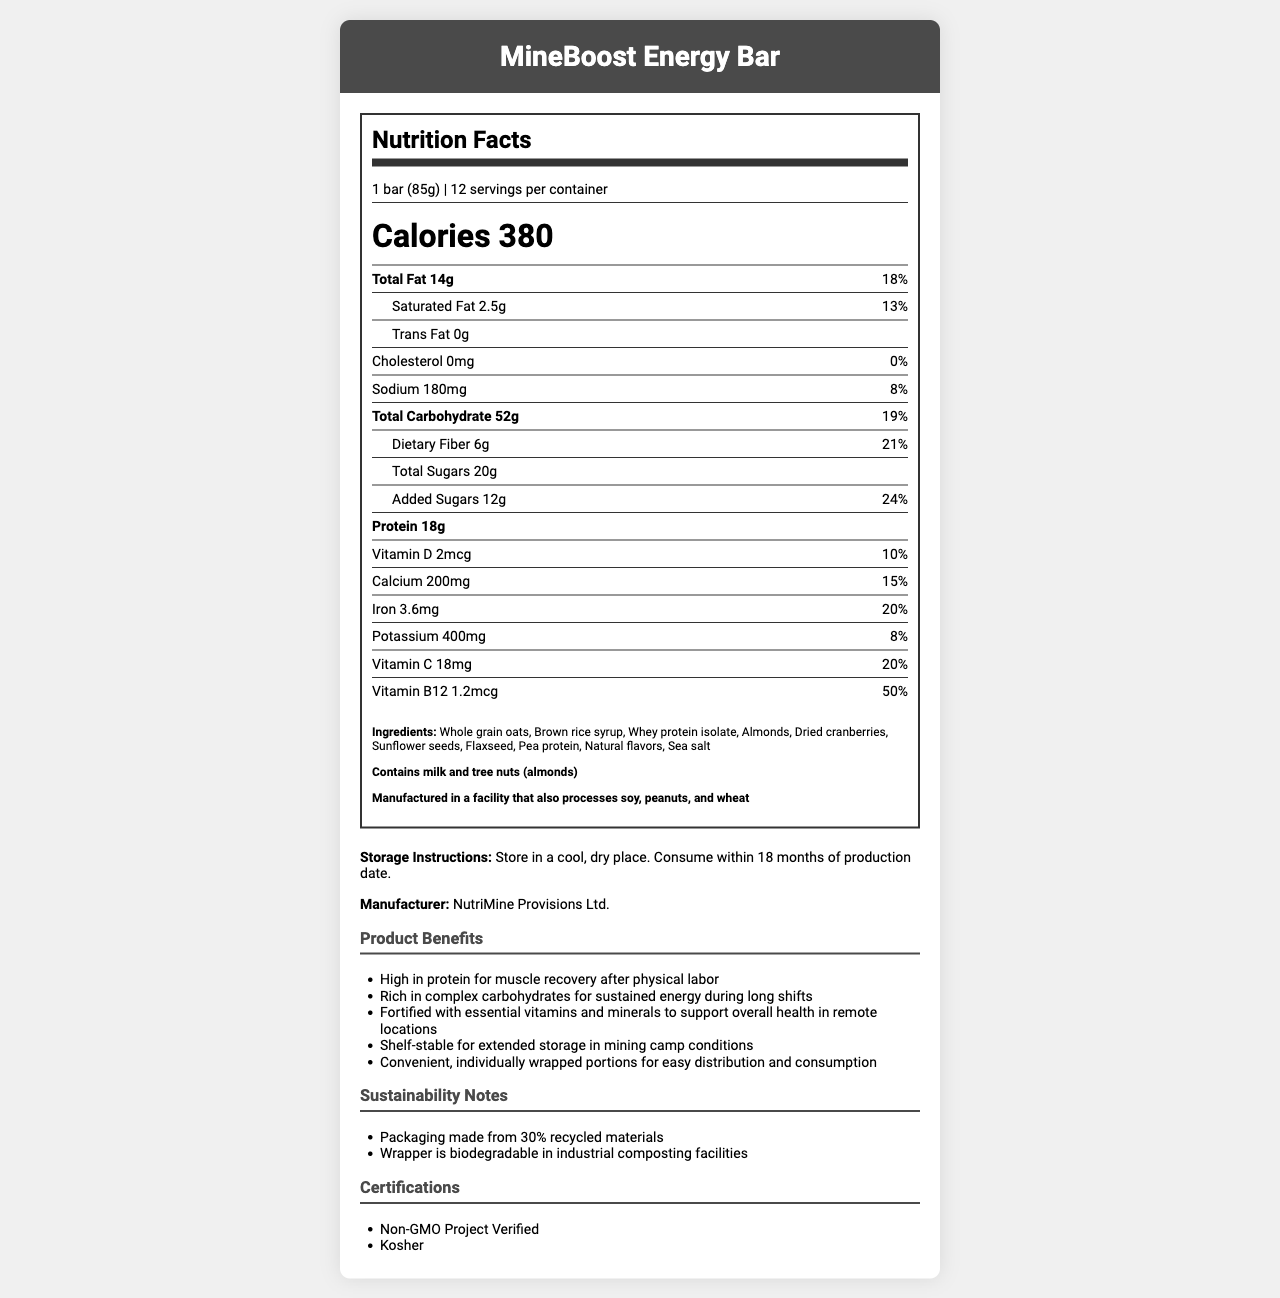what is the serving size of the MineBoost Energy Bar? The serving size of the MineBoost Energy Bar is indicated as "1 bar (85g)" in the Nutrition Facts section.
Answer: 1 bar (85g) how many calories are in one serving of the MineBoost Energy Bar? The Nutrition Facts section shows that one serving contains 380 calories.
Answer: 380 what is the amount of protein in one bar? The protein content per serving is listed as 18g in the Nutrition Facts section.
Answer: 18g list the vitamins and minerals included in the MineBoost Energy Bar. The Nutrition Facts section lists these vitamins and minerals with their amounts and daily values.
Answer: Vitamin D, Calcium, Iron, Potassium, Vitamin C, Vitamin B12 what is the daily value percentage for dietary fiber? The daily value percentage for dietary fiber is stated as 21% in the Nutrition Facts section.
Answer: 21% what are the main sources of protein in the MineBoost Energy Bar? The ingredients list includes "Whey protein isolate" and "Pea protein" as the main sources of protein.
Answer: Whey protein isolate, Pea protein which of the following is not an ingredient in the MineBoost Energy Bar? A. Almonds B. Peanut Butter C. Dried Cranberries D. Flaxseed "Peanut Butter" is not listed as one of the ingredients, while the other options are present.
Answer: B. Peanut Butter what is the main carbohydrate source in this energy bar? From the ingredients list, "Whole grain oats" and "Brown rice syrup" are the main carbohydrate sources.
Answer: Whole grain oats, Brown rice syrup true or false: The MineBoost Energy Bar contains artificial flavors. The ingredients list states "Natural flavors" only, not artificial flavors.
Answer: False how should the MineBoost Energy Bar be stored? The storage instructions clearly state to store the bars in a cool, dry place and to consume them within 18 months of production.
Answer: Store in a cool, dry place. Consume within 18 months of production date. can the MineBoost Energy Bar be consumed by someone with a peanut allergy? While the bar itself doesn't contain peanuts, it's manufactured in a facility that processes peanuts, so there's a risk of cross-contamination.
Answer: Not necessarily safe, as it's manufactured in a facility that processes peanuts. which certification does the MineBoost Energy Bar have? A. USDA Organic B. Non-GMO Project Verified C. Gluten-Free The certifications listed include "Non-GMO Project Verified" but not the other options.
Answer: B. Non-GMO Project Verified summarize the main benefits of the MineBoost Energy Bar. The product benefits section lists these attributes, emphasizing its suitability for physical labor, sustained energy, health support, long shelf life, and convenience.
Answer: The MineBoost Energy Bar is high in protein for muscle recovery, rich in complex carbohydrates for sustained energy, fortified with essential vitamins and minerals, shelf-stable for extended storage, and convenient with individually wrapped portions. how many servings are in a container of the MineBoost Energy Bar? The Nutrition Facts section states there are 12 servings per container.
Answer: 12 servings what are the sustainability features of the packaging? The sustainability notes detail these two features of the packaging.
Answer: Packaging made from 30% recycled materials and the wrapper is biodegradable in industrial composting facilities. what is the production date of this specific energy bar? The document does not provide any information about the specific production date of the bar.
Answer: Cannot be determined 